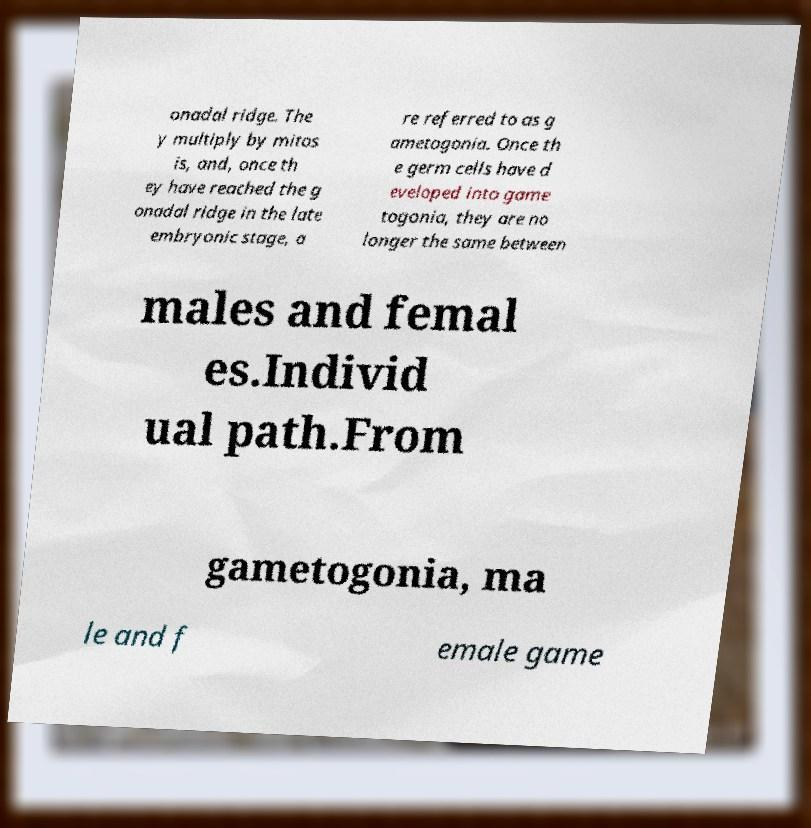What messages or text are displayed in this image? I need them in a readable, typed format. onadal ridge. The y multiply by mitos is, and, once th ey have reached the g onadal ridge in the late embryonic stage, a re referred to as g ametogonia. Once th e germ cells have d eveloped into game togonia, they are no longer the same between males and femal es.Individ ual path.From gametogonia, ma le and f emale game 